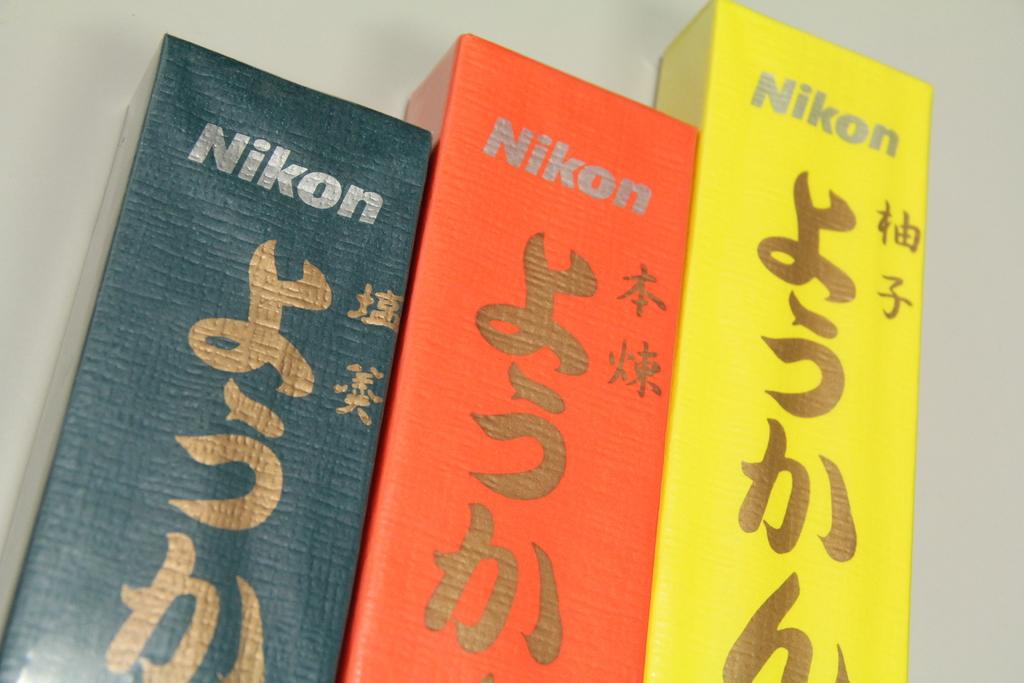What is in these boxes?
Make the answer very short. Nikon. What brand is on these boxes?
Provide a succinct answer. Nikon. 